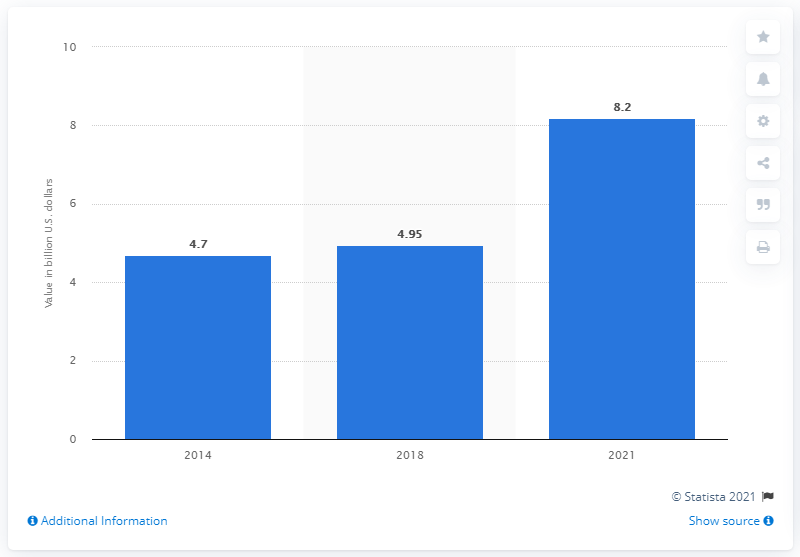Highlight a few significant elements in this photo. According to available data, the value of India's home textile industry in 2014 was approximately 4.7 billion US dollars. 